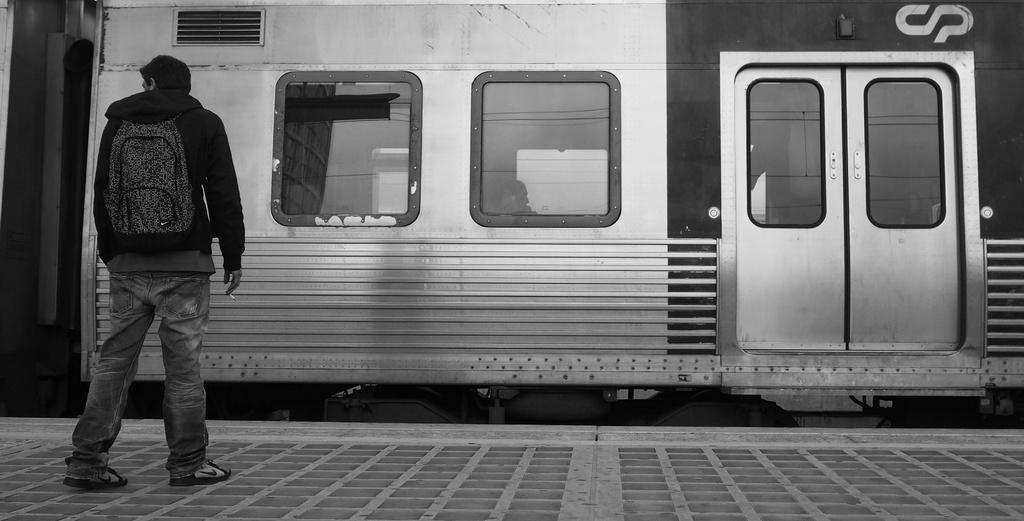What is the main subject on the left side of the image? There is a person standing on a platform on the left side of the image. What can be seen in the middle of the image? There is a train on the track in the middle of the image. What is the color scheme of the image? The image is black and white. What type of religious symbol can be seen on the train in the image? There is no religious symbol present on the train in the image, as it is a black and white image with no such details visible. What scent is associated with the person standing on the platform in the image? There is no information about the scent associated with the person standing on the platform in the image, as it is a visual medium and does not convey smells. 